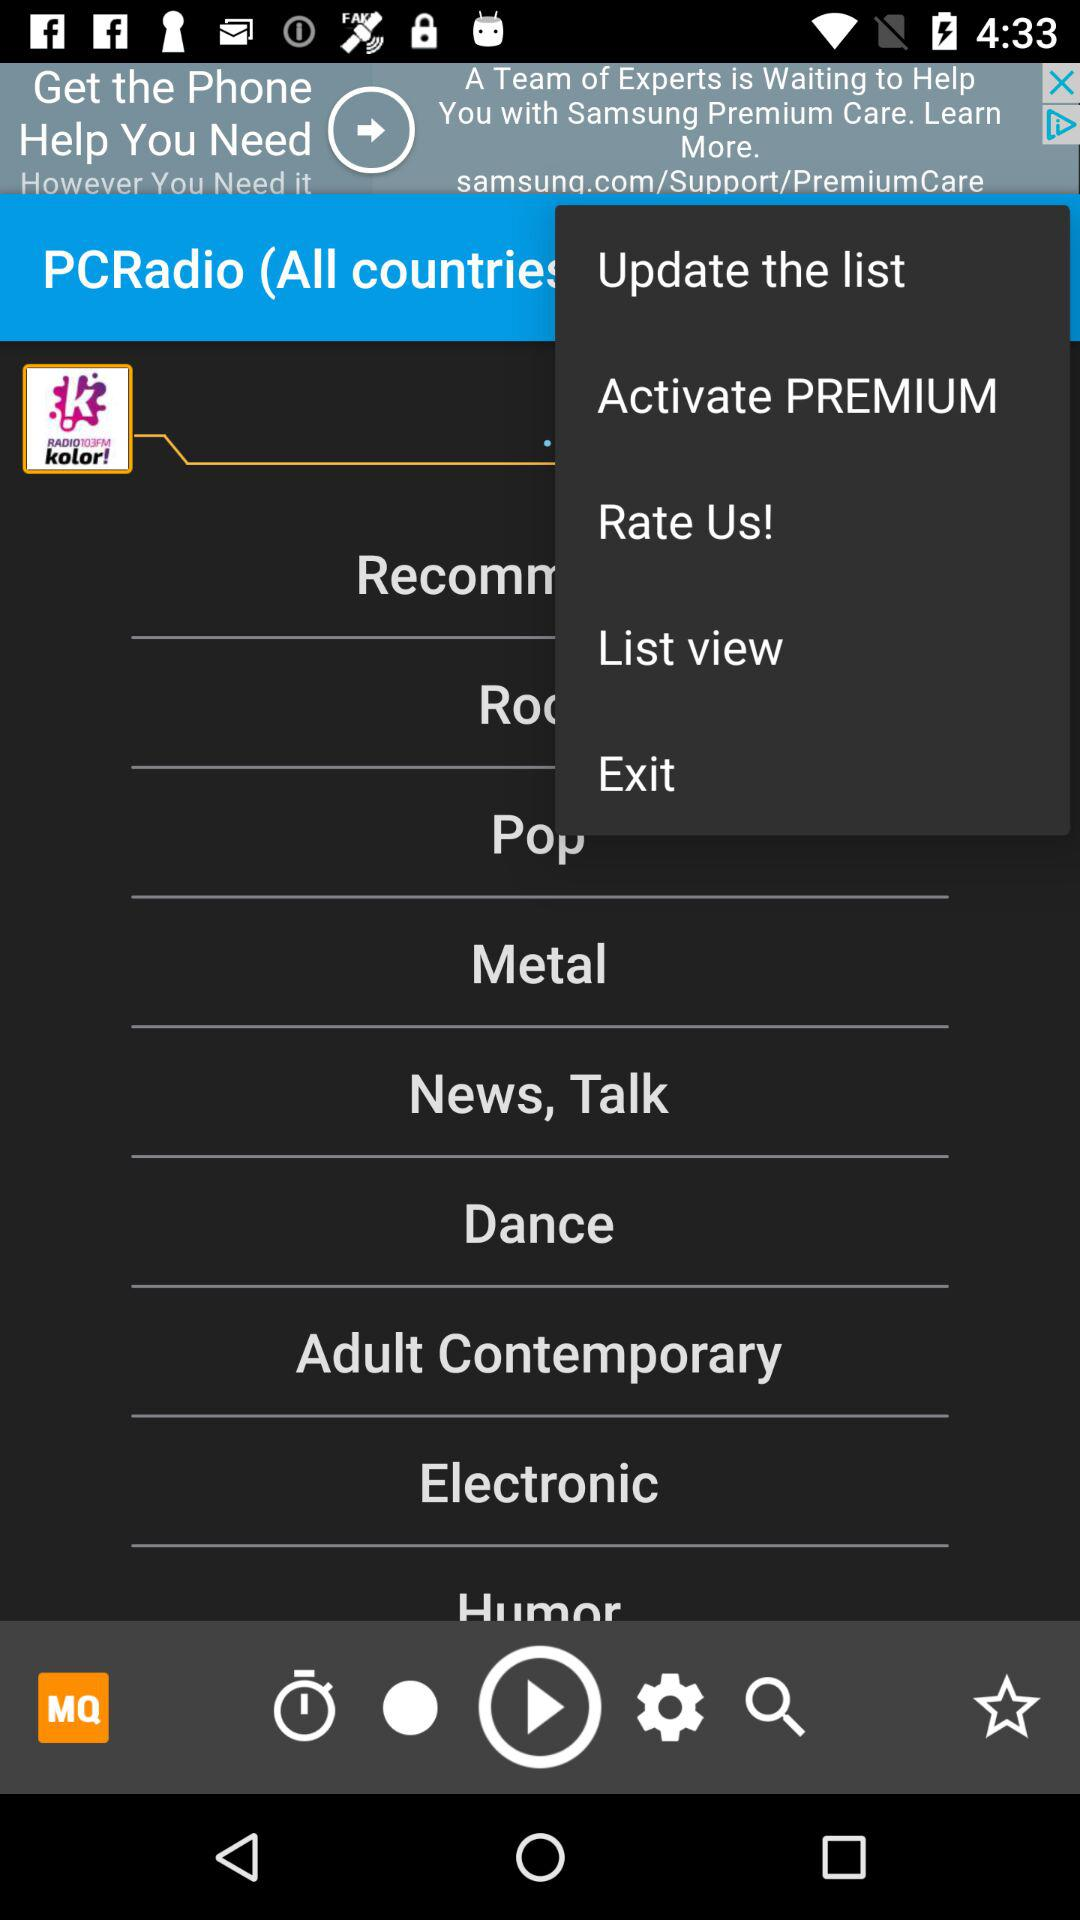What is the name of the application? The name of the application is "PCRadio". 